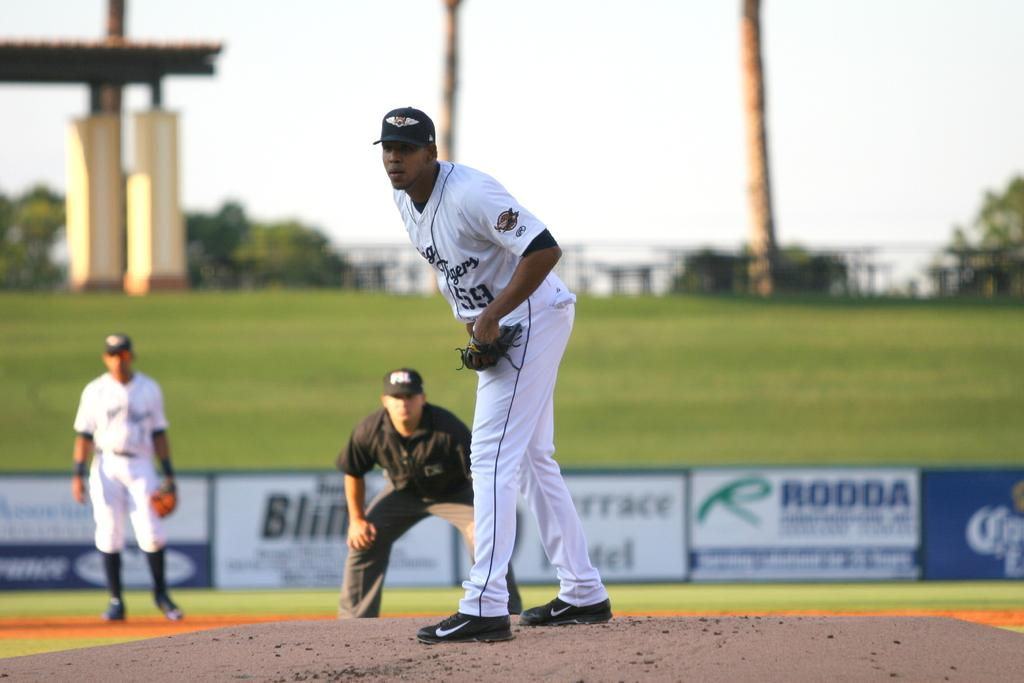<image>
Present a compact description of the photo's key features. Player number 59 is preparing to pitch the baseball from the mound. 